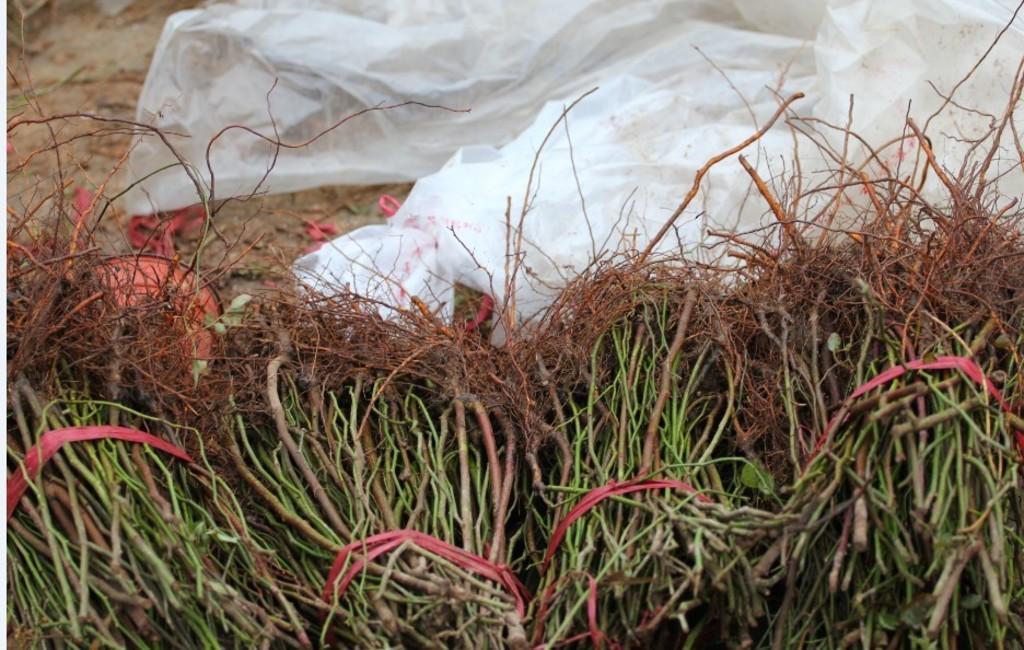Can you describe this image briefly? This picture is clicked outside. In the foreground we can see the stems tied with the ropes and there is a white color object lying on the ground. 